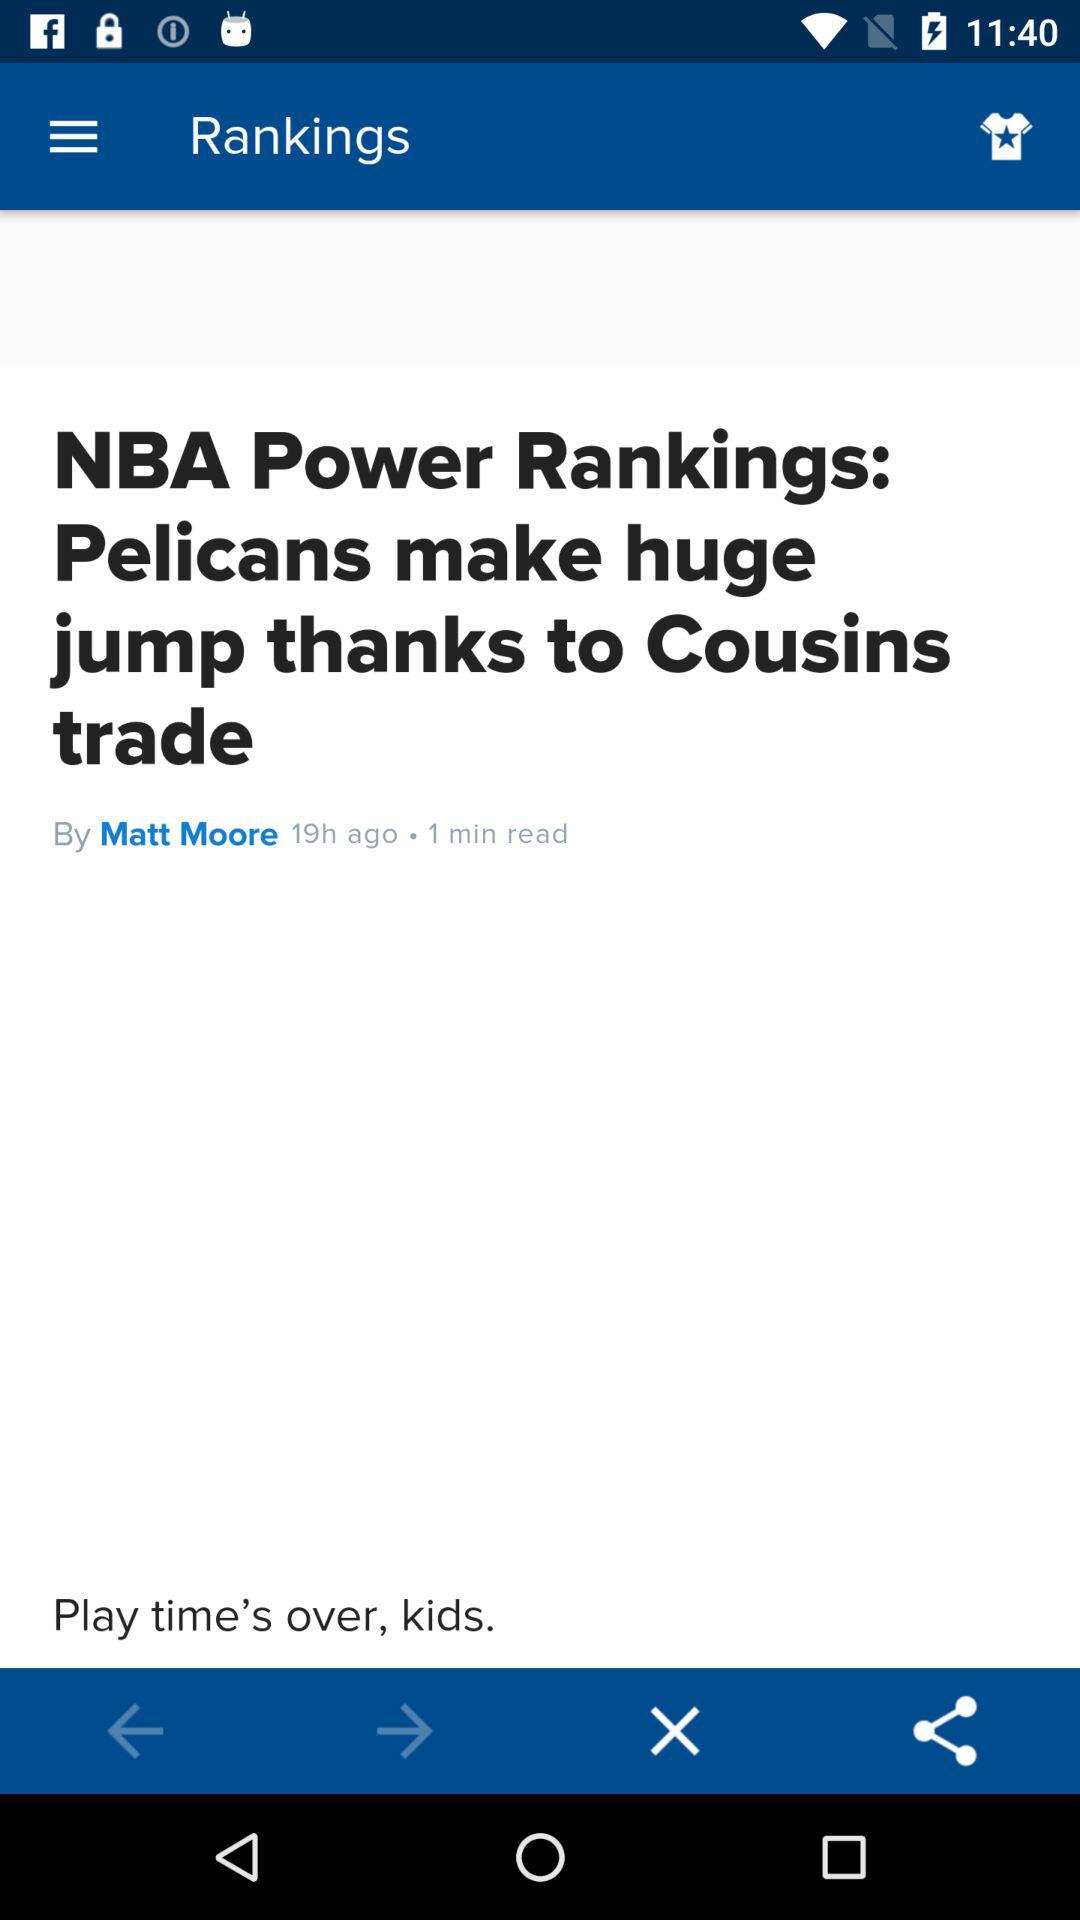What is the headline? The headline is "NBA Power Rankings: Pelicans make huge jump thanks to Cousins trade". 